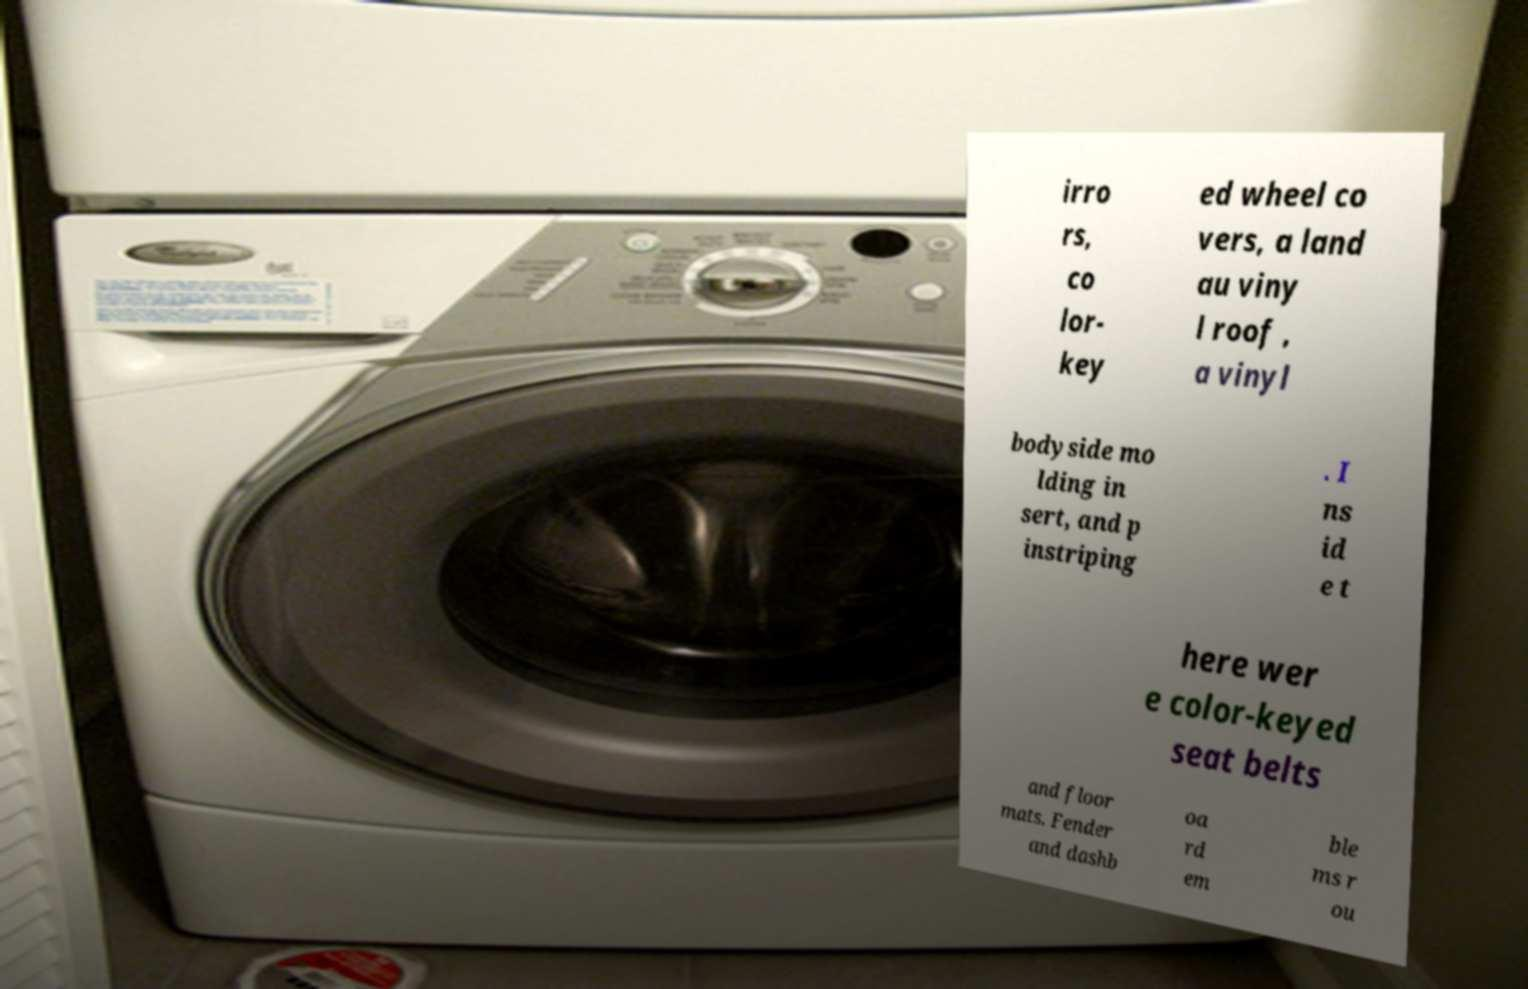Can you read and provide the text displayed in the image?This photo seems to have some interesting text. Can you extract and type it out for me? irro rs, co lor- key ed wheel co vers, a land au viny l roof , a vinyl bodyside mo lding in sert, and p instriping . I ns id e t here wer e color-keyed seat belts and floor mats. Fender and dashb oa rd em ble ms r ou 